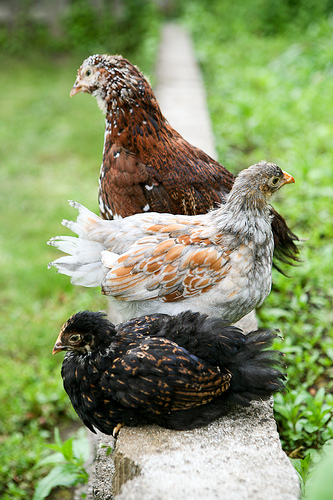<image>
Can you confirm if the bird one is in front of the bird two? Yes. The bird one is positioned in front of the bird two, appearing closer to the camera viewpoint. 